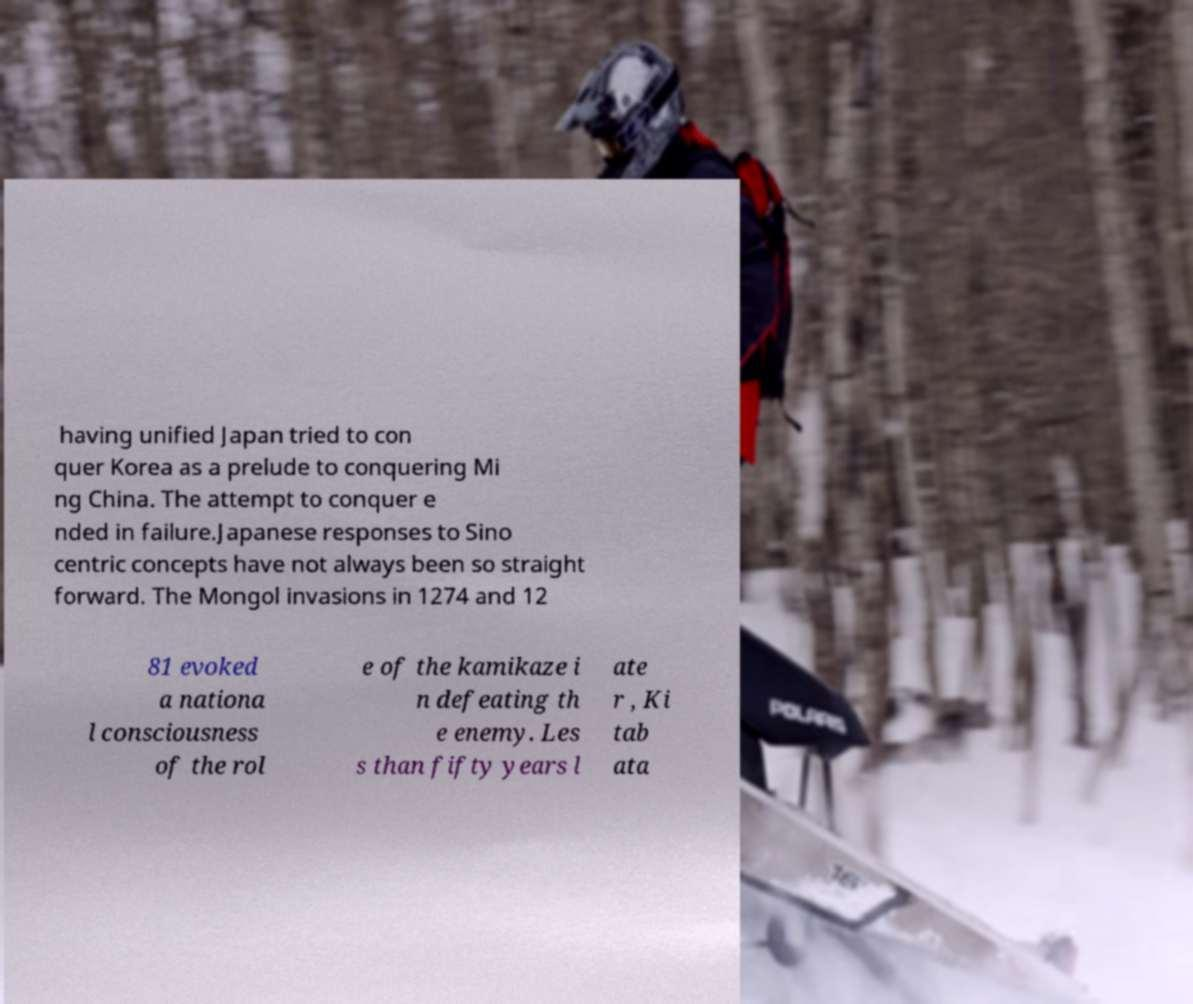Can you accurately transcribe the text from the provided image for me? having unified Japan tried to con quer Korea as a prelude to conquering Mi ng China. The attempt to conquer e nded in failure.Japanese responses to Sino centric concepts have not always been so straight forward. The Mongol invasions in 1274 and 12 81 evoked a nationa l consciousness of the rol e of the kamikaze i n defeating th e enemy. Les s than fifty years l ate r , Ki tab ata 